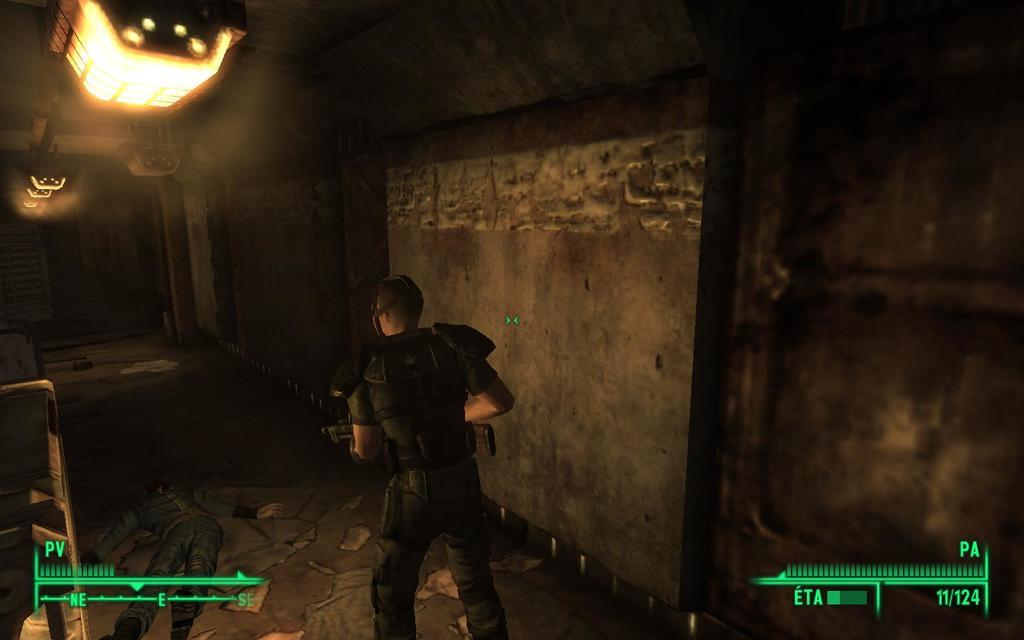What can be seen in the image that represents information or ideas? There are symbols in the image that represent information or ideas. What is the man in the image holding in his hand? The man is holding a gun in his hand. Where is the man standing in the image? The man is standing on the ground. What is the position of the person in front of the man with the gun? There is a person lying in front of the man with the gun. What can be seen in the image that provides illumination? Lights are visible in the image. What type of structure is present in the image? There is a wall in the image. What else can be seen in the image besides the people and the wall? There are objects present in the image. How many pigs are present in the image? There are no pigs present in the image. What type of cheese is being used as a prop in the image? There is no cheese present in the image. 